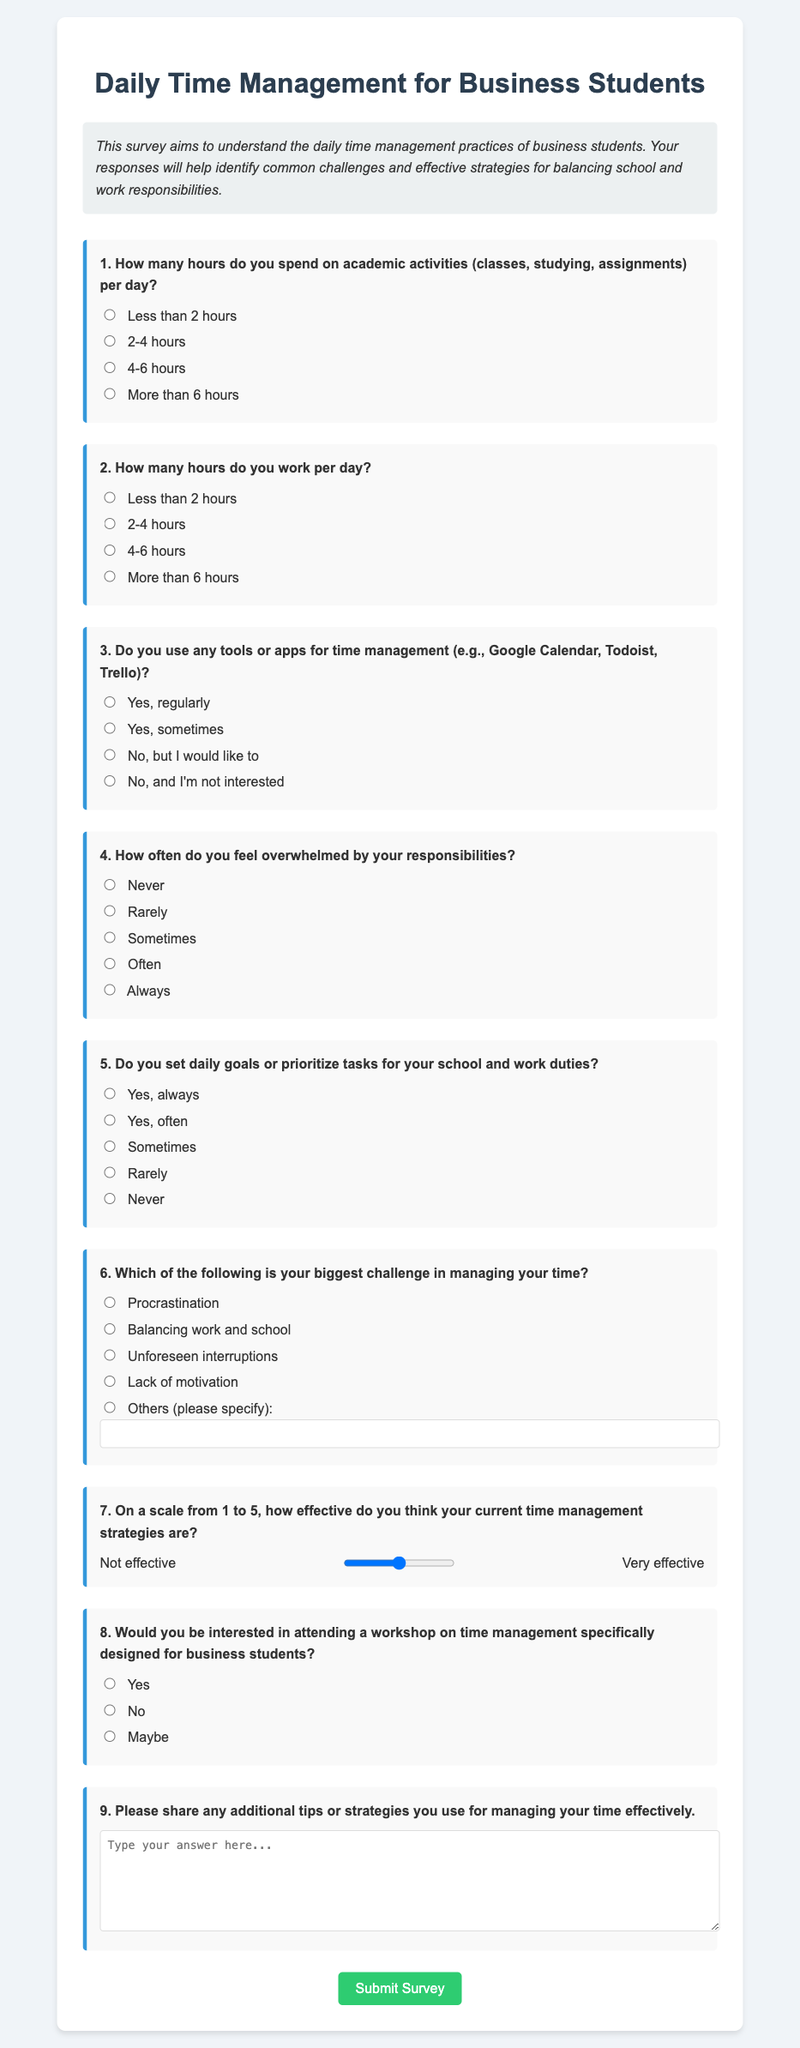What is the title of the survey? The title of the survey is displayed prominently at the top of the document.
Answer: Daily Time Management for Business Students How many questions are in the survey? The document lists a total of nine questions that participants are asked to answer.
Answer: 9 What is the purpose of the survey? The intention behind the survey is summarized in the descriptive section below the title.
Answer: To understand daily time management practices What type of input is provided for question 7? The method of input for question 7 involves a specific tool for rating effectiveness.
Answer: A range slider What are the options for question 4 regarding feeling overwhelmed? The options are laid out for respondents to select regarding their feelings of being overwhelmed.
Answer: Never, Rarely, Sometimes, Often, Always What additional question can participants answer in the survey? The survey allows participants to provide extra feedback in a designated area.
Answer: Additional tips or strategies How is the look of the survey defined visually? The styling and layout options are set explicitly in the head section of the document.
Answer: Includes a container, background color, and font styles What is the submit button color? The color is specified in the code for the button that participants click to submit their responses.
Answer: Green Which question relates to tools or apps for time management? The specific question that addresses this topic can be identified among the listed questions.
Answer: Question 3 